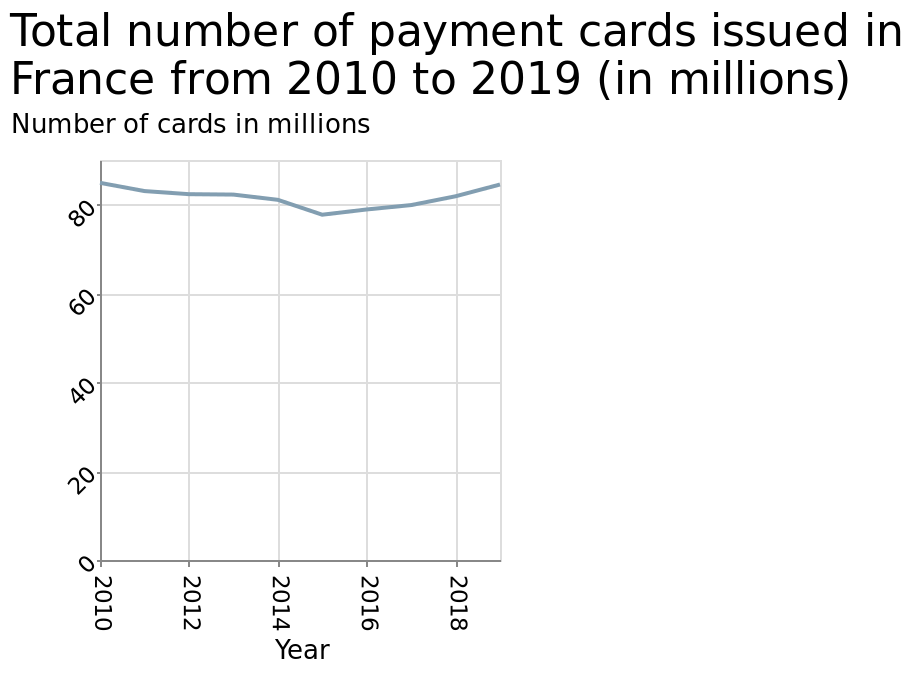<image>
What does the line diagram titled "Total number of payment cards issued in France from 2010 to 2019 (in millions)" indicate?  The line diagram represents the number of payment cards issued in France from 2010 to 2019, measured in millions. At what point does the number of cards issued in France begin to rise again? The number of cards issued in France begins to rise again from 2016 onwards. 